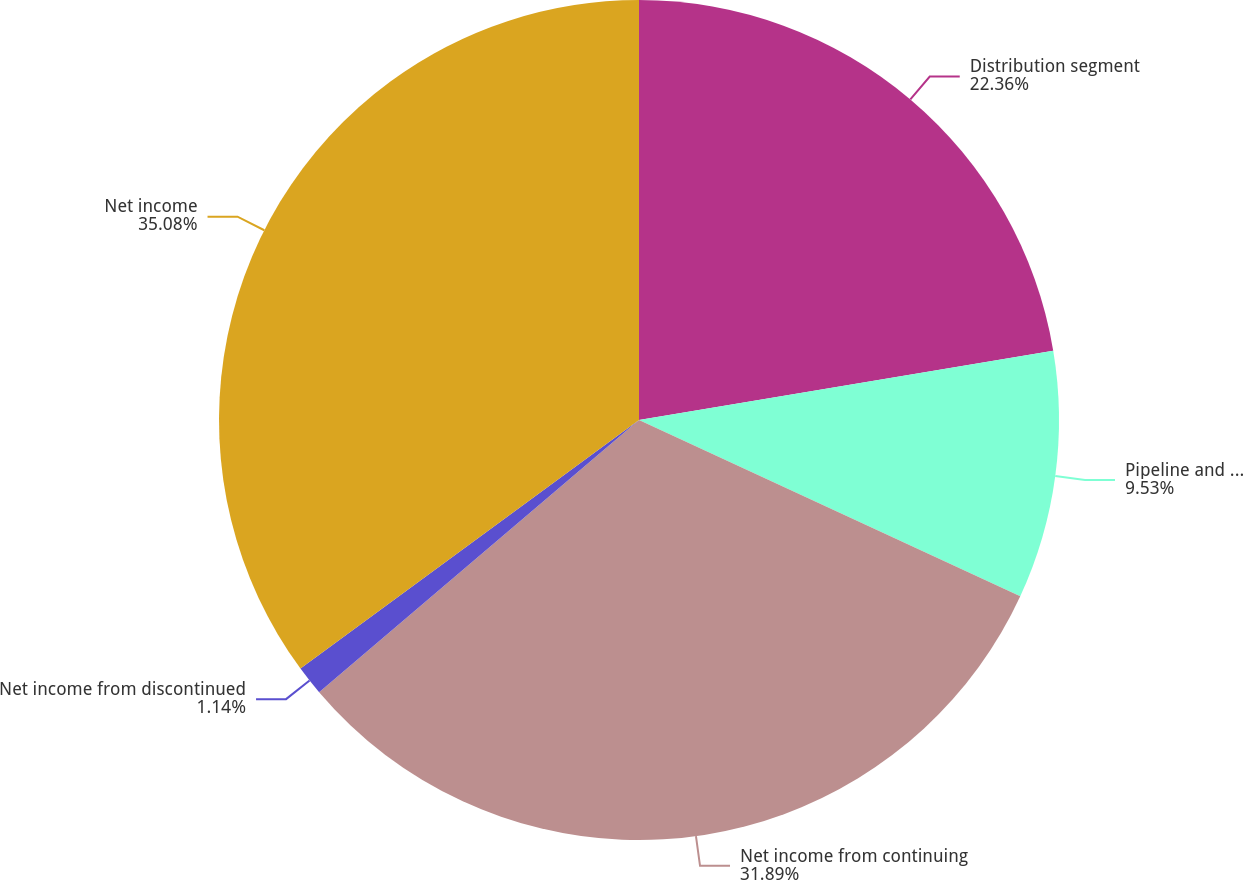<chart> <loc_0><loc_0><loc_500><loc_500><pie_chart><fcel>Distribution segment<fcel>Pipeline and storage segment<fcel>Net income from continuing<fcel>Net income from discontinued<fcel>Net income<nl><fcel>22.36%<fcel>9.53%<fcel>31.89%<fcel>1.14%<fcel>35.08%<nl></chart> 